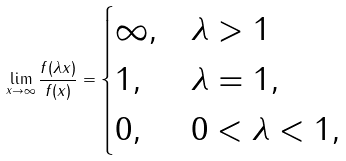<formula> <loc_0><loc_0><loc_500><loc_500>\lim _ { x \to \infty } \frac { f ( \lambda x ) } { f ( x ) } = \begin{cases} \infty , & \lambda > 1 \\ 1 , & \lambda = 1 , \\ 0 , & 0 < \lambda < 1 , \end{cases}</formula> 